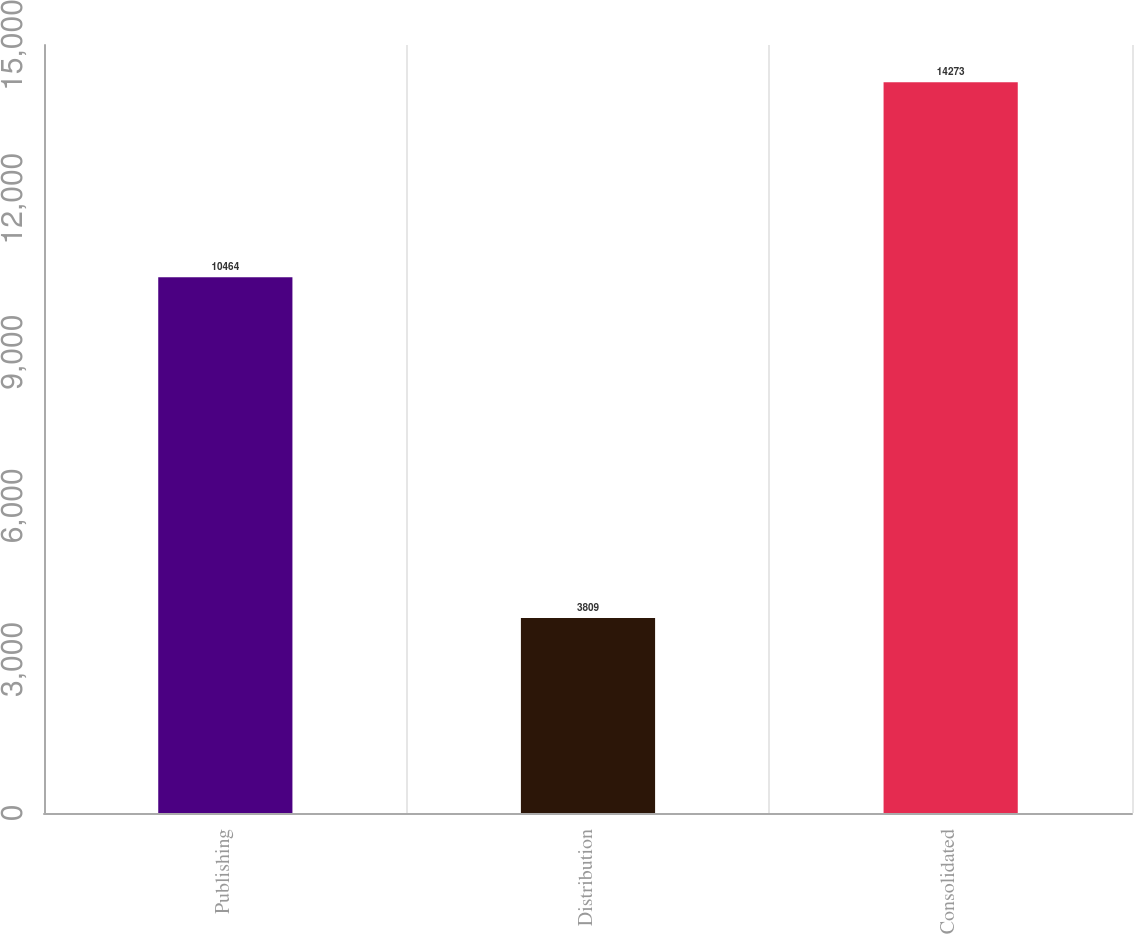Convert chart. <chart><loc_0><loc_0><loc_500><loc_500><bar_chart><fcel>Publishing<fcel>Distribution<fcel>Consolidated<nl><fcel>10464<fcel>3809<fcel>14273<nl></chart> 